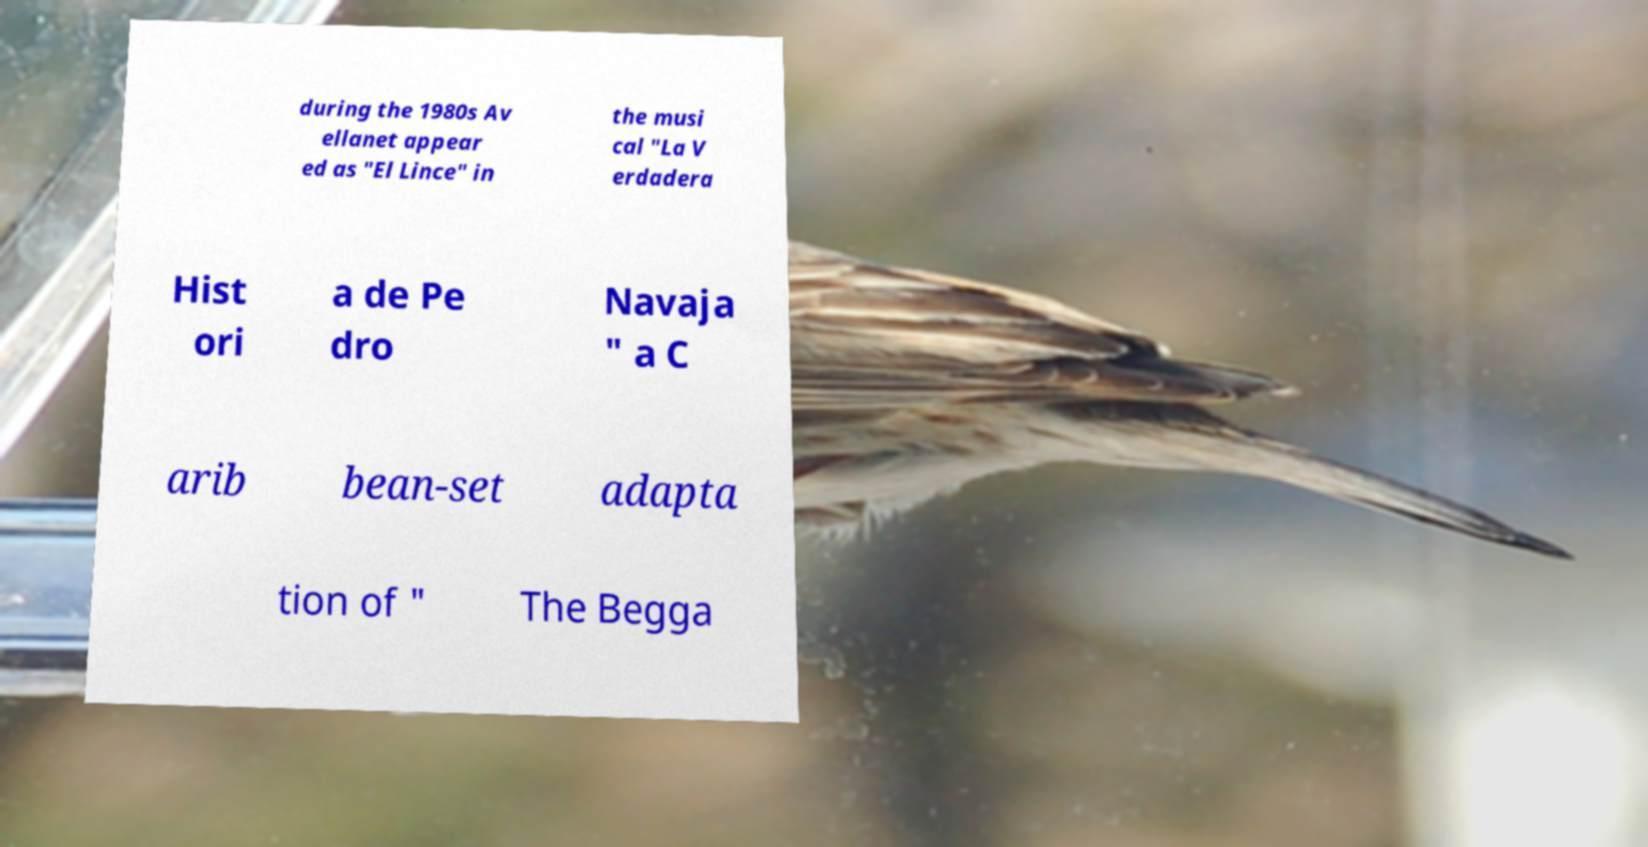Could you extract and type out the text from this image? during the 1980s Av ellanet appear ed as "El Lince" in the musi cal "La V erdadera Hist ori a de Pe dro Navaja " a C arib bean-set adapta tion of " The Begga 